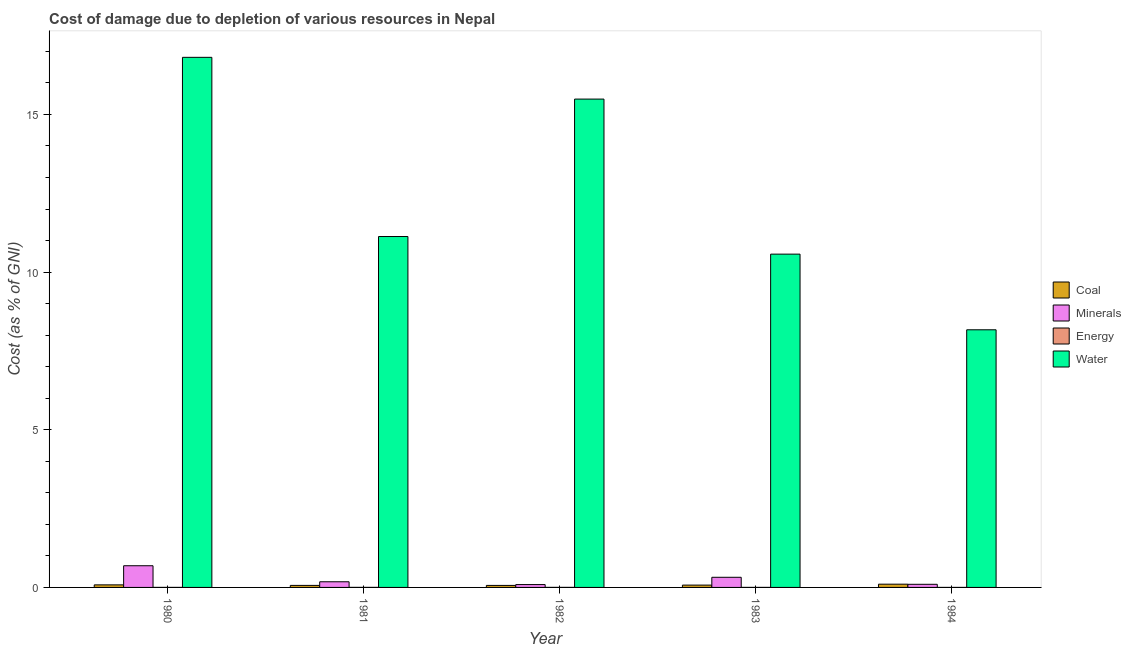How many different coloured bars are there?
Provide a short and direct response. 4. How many bars are there on the 1st tick from the left?
Provide a succinct answer. 4. What is the label of the 4th group of bars from the left?
Keep it short and to the point. 1983. What is the cost of damage due to depletion of coal in 1980?
Offer a terse response. 0.08. Across all years, what is the maximum cost of damage due to depletion of energy?
Your response must be concise. 0. Across all years, what is the minimum cost of damage due to depletion of energy?
Your response must be concise. 0. In which year was the cost of damage due to depletion of minerals maximum?
Make the answer very short. 1980. What is the total cost of damage due to depletion of coal in the graph?
Keep it short and to the point. 0.39. What is the difference between the cost of damage due to depletion of minerals in 1980 and that in 1984?
Your response must be concise. 0.59. What is the difference between the cost of damage due to depletion of coal in 1981 and the cost of damage due to depletion of water in 1983?
Your answer should be compact. -0.01. What is the average cost of damage due to depletion of energy per year?
Offer a very short reply. 0. In the year 1982, what is the difference between the cost of damage due to depletion of energy and cost of damage due to depletion of minerals?
Your answer should be very brief. 0. In how many years, is the cost of damage due to depletion of energy greater than 15 %?
Provide a short and direct response. 0. What is the ratio of the cost of damage due to depletion of coal in 1980 to that in 1981?
Your answer should be very brief. 1.26. What is the difference between the highest and the second highest cost of damage due to depletion of water?
Offer a very short reply. 1.32. What is the difference between the highest and the lowest cost of damage due to depletion of energy?
Make the answer very short. 0. Is the sum of the cost of damage due to depletion of coal in 1980 and 1982 greater than the maximum cost of damage due to depletion of water across all years?
Ensure brevity in your answer.  Yes. What does the 4th bar from the left in 1982 represents?
Your answer should be very brief. Water. What does the 1st bar from the right in 1980 represents?
Ensure brevity in your answer.  Water. Are all the bars in the graph horizontal?
Your answer should be very brief. No. How many years are there in the graph?
Your response must be concise. 5. Are the values on the major ticks of Y-axis written in scientific E-notation?
Your answer should be very brief. No. How many legend labels are there?
Keep it short and to the point. 4. What is the title of the graph?
Ensure brevity in your answer.  Cost of damage due to depletion of various resources in Nepal . Does "Agricultural land" appear as one of the legend labels in the graph?
Your response must be concise. No. What is the label or title of the Y-axis?
Ensure brevity in your answer.  Cost (as % of GNI). What is the Cost (as % of GNI) of Coal in 1980?
Offer a very short reply. 0.08. What is the Cost (as % of GNI) of Minerals in 1980?
Provide a succinct answer. 0.69. What is the Cost (as % of GNI) of Energy in 1980?
Provide a succinct answer. 0. What is the Cost (as % of GNI) in Water in 1980?
Make the answer very short. 16.81. What is the Cost (as % of GNI) in Coal in 1981?
Keep it short and to the point. 0.06. What is the Cost (as % of GNI) in Minerals in 1981?
Give a very brief answer. 0.18. What is the Cost (as % of GNI) in Energy in 1981?
Offer a very short reply. 0. What is the Cost (as % of GNI) of Water in 1981?
Provide a succinct answer. 11.13. What is the Cost (as % of GNI) in Coal in 1982?
Provide a succinct answer. 0.06. What is the Cost (as % of GNI) of Minerals in 1982?
Offer a very short reply. 0.09. What is the Cost (as % of GNI) of Energy in 1982?
Keep it short and to the point. 0. What is the Cost (as % of GNI) in Water in 1982?
Give a very brief answer. 15.49. What is the Cost (as % of GNI) of Coal in 1983?
Your answer should be compact. 0.07. What is the Cost (as % of GNI) of Minerals in 1983?
Keep it short and to the point. 0.32. What is the Cost (as % of GNI) in Energy in 1983?
Your response must be concise. 0. What is the Cost (as % of GNI) in Water in 1983?
Ensure brevity in your answer.  10.57. What is the Cost (as % of GNI) of Coal in 1984?
Your answer should be very brief. 0.1. What is the Cost (as % of GNI) of Minerals in 1984?
Give a very brief answer. 0.1. What is the Cost (as % of GNI) of Energy in 1984?
Ensure brevity in your answer.  0. What is the Cost (as % of GNI) in Water in 1984?
Provide a short and direct response. 8.17. Across all years, what is the maximum Cost (as % of GNI) of Coal?
Keep it short and to the point. 0.1. Across all years, what is the maximum Cost (as % of GNI) of Minerals?
Your response must be concise. 0.69. Across all years, what is the maximum Cost (as % of GNI) in Energy?
Ensure brevity in your answer.  0. Across all years, what is the maximum Cost (as % of GNI) in Water?
Your response must be concise. 16.81. Across all years, what is the minimum Cost (as % of GNI) in Coal?
Give a very brief answer. 0.06. Across all years, what is the minimum Cost (as % of GNI) of Minerals?
Your answer should be very brief. 0.09. Across all years, what is the minimum Cost (as % of GNI) of Energy?
Give a very brief answer. 0. Across all years, what is the minimum Cost (as % of GNI) in Water?
Provide a succinct answer. 8.17. What is the total Cost (as % of GNI) in Coal in the graph?
Your response must be concise. 0.39. What is the total Cost (as % of GNI) of Minerals in the graph?
Provide a short and direct response. 1.38. What is the total Cost (as % of GNI) of Energy in the graph?
Give a very brief answer. 0. What is the total Cost (as % of GNI) of Water in the graph?
Make the answer very short. 62.17. What is the difference between the Cost (as % of GNI) of Coal in 1980 and that in 1981?
Ensure brevity in your answer.  0.02. What is the difference between the Cost (as % of GNI) in Minerals in 1980 and that in 1981?
Ensure brevity in your answer.  0.51. What is the difference between the Cost (as % of GNI) in Energy in 1980 and that in 1981?
Offer a very short reply. -0. What is the difference between the Cost (as % of GNI) of Water in 1980 and that in 1981?
Your answer should be very brief. 5.68. What is the difference between the Cost (as % of GNI) of Coal in 1980 and that in 1982?
Give a very brief answer. 0.02. What is the difference between the Cost (as % of GNI) in Minerals in 1980 and that in 1982?
Make the answer very short. 0.6. What is the difference between the Cost (as % of GNI) of Energy in 1980 and that in 1982?
Offer a very short reply. -0. What is the difference between the Cost (as % of GNI) in Water in 1980 and that in 1982?
Provide a short and direct response. 1.32. What is the difference between the Cost (as % of GNI) in Coal in 1980 and that in 1983?
Ensure brevity in your answer.  0.01. What is the difference between the Cost (as % of GNI) in Minerals in 1980 and that in 1983?
Make the answer very short. 0.37. What is the difference between the Cost (as % of GNI) in Energy in 1980 and that in 1983?
Your answer should be very brief. -0. What is the difference between the Cost (as % of GNI) of Water in 1980 and that in 1983?
Ensure brevity in your answer.  6.24. What is the difference between the Cost (as % of GNI) in Coal in 1980 and that in 1984?
Provide a short and direct response. -0.02. What is the difference between the Cost (as % of GNI) of Minerals in 1980 and that in 1984?
Ensure brevity in your answer.  0.59. What is the difference between the Cost (as % of GNI) of Water in 1980 and that in 1984?
Make the answer very short. 8.64. What is the difference between the Cost (as % of GNI) of Coal in 1981 and that in 1982?
Make the answer very short. 0. What is the difference between the Cost (as % of GNI) of Minerals in 1981 and that in 1982?
Offer a terse response. 0.09. What is the difference between the Cost (as % of GNI) of Energy in 1981 and that in 1982?
Your answer should be compact. -0. What is the difference between the Cost (as % of GNI) of Water in 1981 and that in 1982?
Offer a terse response. -4.36. What is the difference between the Cost (as % of GNI) of Coal in 1981 and that in 1983?
Offer a very short reply. -0.01. What is the difference between the Cost (as % of GNI) of Minerals in 1981 and that in 1983?
Keep it short and to the point. -0.14. What is the difference between the Cost (as % of GNI) of Water in 1981 and that in 1983?
Ensure brevity in your answer.  0.56. What is the difference between the Cost (as % of GNI) in Coal in 1981 and that in 1984?
Provide a succinct answer. -0.04. What is the difference between the Cost (as % of GNI) of Minerals in 1981 and that in 1984?
Your response must be concise. 0.08. What is the difference between the Cost (as % of GNI) of Energy in 1981 and that in 1984?
Your answer should be compact. 0. What is the difference between the Cost (as % of GNI) in Water in 1981 and that in 1984?
Provide a short and direct response. 2.96. What is the difference between the Cost (as % of GNI) in Coal in 1982 and that in 1983?
Offer a very short reply. -0.01. What is the difference between the Cost (as % of GNI) in Minerals in 1982 and that in 1983?
Offer a terse response. -0.23. What is the difference between the Cost (as % of GNI) in Energy in 1982 and that in 1983?
Offer a very short reply. 0. What is the difference between the Cost (as % of GNI) in Water in 1982 and that in 1983?
Provide a short and direct response. 4.92. What is the difference between the Cost (as % of GNI) in Coal in 1982 and that in 1984?
Provide a succinct answer. -0.04. What is the difference between the Cost (as % of GNI) of Minerals in 1982 and that in 1984?
Make the answer very short. -0.01. What is the difference between the Cost (as % of GNI) in Water in 1982 and that in 1984?
Provide a succinct answer. 7.32. What is the difference between the Cost (as % of GNI) in Coal in 1983 and that in 1984?
Offer a terse response. -0.03. What is the difference between the Cost (as % of GNI) in Minerals in 1983 and that in 1984?
Offer a very short reply. 0.22. What is the difference between the Cost (as % of GNI) of Water in 1983 and that in 1984?
Ensure brevity in your answer.  2.4. What is the difference between the Cost (as % of GNI) of Coal in 1980 and the Cost (as % of GNI) of Minerals in 1981?
Your answer should be very brief. -0.1. What is the difference between the Cost (as % of GNI) in Coal in 1980 and the Cost (as % of GNI) in Energy in 1981?
Offer a very short reply. 0.08. What is the difference between the Cost (as % of GNI) of Coal in 1980 and the Cost (as % of GNI) of Water in 1981?
Make the answer very short. -11.05. What is the difference between the Cost (as % of GNI) in Minerals in 1980 and the Cost (as % of GNI) in Energy in 1981?
Ensure brevity in your answer.  0.69. What is the difference between the Cost (as % of GNI) in Minerals in 1980 and the Cost (as % of GNI) in Water in 1981?
Keep it short and to the point. -10.44. What is the difference between the Cost (as % of GNI) in Energy in 1980 and the Cost (as % of GNI) in Water in 1981?
Your response must be concise. -11.13. What is the difference between the Cost (as % of GNI) of Coal in 1980 and the Cost (as % of GNI) of Minerals in 1982?
Provide a short and direct response. -0.01. What is the difference between the Cost (as % of GNI) in Coal in 1980 and the Cost (as % of GNI) in Energy in 1982?
Make the answer very short. 0.08. What is the difference between the Cost (as % of GNI) in Coal in 1980 and the Cost (as % of GNI) in Water in 1982?
Ensure brevity in your answer.  -15.41. What is the difference between the Cost (as % of GNI) of Minerals in 1980 and the Cost (as % of GNI) of Energy in 1982?
Offer a terse response. 0.69. What is the difference between the Cost (as % of GNI) in Minerals in 1980 and the Cost (as % of GNI) in Water in 1982?
Keep it short and to the point. -14.8. What is the difference between the Cost (as % of GNI) of Energy in 1980 and the Cost (as % of GNI) of Water in 1982?
Your response must be concise. -15.49. What is the difference between the Cost (as % of GNI) in Coal in 1980 and the Cost (as % of GNI) in Minerals in 1983?
Provide a succinct answer. -0.24. What is the difference between the Cost (as % of GNI) in Coal in 1980 and the Cost (as % of GNI) in Energy in 1983?
Ensure brevity in your answer.  0.08. What is the difference between the Cost (as % of GNI) of Coal in 1980 and the Cost (as % of GNI) of Water in 1983?
Your answer should be compact. -10.49. What is the difference between the Cost (as % of GNI) in Minerals in 1980 and the Cost (as % of GNI) in Energy in 1983?
Provide a short and direct response. 0.69. What is the difference between the Cost (as % of GNI) in Minerals in 1980 and the Cost (as % of GNI) in Water in 1983?
Your answer should be compact. -9.88. What is the difference between the Cost (as % of GNI) in Energy in 1980 and the Cost (as % of GNI) in Water in 1983?
Ensure brevity in your answer.  -10.57. What is the difference between the Cost (as % of GNI) in Coal in 1980 and the Cost (as % of GNI) in Minerals in 1984?
Your response must be concise. -0.02. What is the difference between the Cost (as % of GNI) in Coal in 1980 and the Cost (as % of GNI) in Energy in 1984?
Ensure brevity in your answer.  0.08. What is the difference between the Cost (as % of GNI) in Coal in 1980 and the Cost (as % of GNI) in Water in 1984?
Ensure brevity in your answer.  -8.09. What is the difference between the Cost (as % of GNI) of Minerals in 1980 and the Cost (as % of GNI) of Energy in 1984?
Your answer should be very brief. 0.69. What is the difference between the Cost (as % of GNI) in Minerals in 1980 and the Cost (as % of GNI) in Water in 1984?
Provide a succinct answer. -7.48. What is the difference between the Cost (as % of GNI) in Energy in 1980 and the Cost (as % of GNI) in Water in 1984?
Offer a very short reply. -8.17. What is the difference between the Cost (as % of GNI) of Coal in 1981 and the Cost (as % of GNI) of Minerals in 1982?
Your answer should be very brief. -0.03. What is the difference between the Cost (as % of GNI) of Coal in 1981 and the Cost (as % of GNI) of Energy in 1982?
Keep it short and to the point. 0.06. What is the difference between the Cost (as % of GNI) of Coal in 1981 and the Cost (as % of GNI) of Water in 1982?
Make the answer very short. -15.42. What is the difference between the Cost (as % of GNI) in Minerals in 1981 and the Cost (as % of GNI) in Energy in 1982?
Provide a succinct answer. 0.18. What is the difference between the Cost (as % of GNI) of Minerals in 1981 and the Cost (as % of GNI) of Water in 1982?
Offer a very short reply. -15.31. What is the difference between the Cost (as % of GNI) in Energy in 1981 and the Cost (as % of GNI) in Water in 1982?
Keep it short and to the point. -15.49. What is the difference between the Cost (as % of GNI) in Coal in 1981 and the Cost (as % of GNI) in Minerals in 1983?
Your answer should be compact. -0.26. What is the difference between the Cost (as % of GNI) in Coal in 1981 and the Cost (as % of GNI) in Energy in 1983?
Your answer should be compact. 0.06. What is the difference between the Cost (as % of GNI) of Coal in 1981 and the Cost (as % of GNI) of Water in 1983?
Offer a very short reply. -10.51. What is the difference between the Cost (as % of GNI) in Minerals in 1981 and the Cost (as % of GNI) in Energy in 1983?
Your response must be concise. 0.18. What is the difference between the Cost (as % of GNI) of Minerals in 1981 and the Cost (as % of GNI) of Water in 1983?
Offer a very short reply. -10.39. What is the difference between the Cost (as % of GNI) in Energy in 1981 and the Cost (as % of GNI) in Water in 1983?
Your response must be concise. -10.57. What is the difference between the Cost (as % of GNI) in Coal in 1981 and the Cost (as % of GNI) in Minerals in 1984?
Make the answer very short. -0.03. What is the difference between the Cost (as % of GNI) in Coal in 1981 and the Cost (as % of GNI) in Energy in 1984?
Make the answer very short. 0.06. What is the difference between the Cost (as % of GNI) in Coal in 1981 and the Cost (as % of GNI) in Water in 1984?
Keep it short and to the point. -8.11. What is the difference between the Cost (as % of GNI) of Minerals in 1981 and the Cost (as % of GNI) of Energy in 1984?
Ensure brevity in your answer.  0.18. What is the difference between the Cost (as % of GNI) of Minerals in 1981 and the Cost (as % of GNI) of Water in 1984?
Give a very brief answer. -7.99. What is the difference between the Cost (as % of GNI) of Energy in 1981 and the Cost (as % of GNI) of Water in 1984?
Give a very brief answer. -8.17. What is the difference between the Cost (as % of GNI) in Coal in 1982 and the Cost (as % of GNI) in Minerals in 1983?
Keep it short and to the point. -0.26. What is the difference between the Cost (as % of GNI) in Coal in 1982 and the Cost (as % of GNI) in Energy in 1983?
Offer a very short reply. 0.06. What is the difference between the Cost (as % of GNI) in Coal in 1982 and the Cost (as % of GNI) in Water in 1983?
Offer a very short reply. -10.51. What is the difference between the Cost (as % of GNI) of Minerals in 1982 and the Cost (as % of GNI) of Energy in 1983?
Keep it short and to the point. 0.09. What is the difference between the Cost (as % of GNI) in Minerals in 1982 and the Cost (as % of GNI) in Water in 1983?
Your response must be concise. -10.48. What is the difference between the Cost (as % of GNI) in Energy in 1982 and the Cost (as % of GNI) in Water in 1983?
Offer a terse response. -10.57. What is the difference between the Cost (as % of GNI) of Coal in 1982 and the Cost (as % of GNI) of Minerals in 1984?
Your response must be concise. -0.04. What is the difference between the Cost (as % of GNI) in Coal in 1982 and the Cost (as % of GNI) in Energy in 1984?
Provide a short and direct response. 0.06. What is the difference between the Cost (as % of GNI) in Coal in 1982 and the Cost (as % of GNI) in Water in 1984?
Offer a very short reply. -8.11. What is the difference between the Cost (as % of GNI) in Minerals in 1982 and the Cost (as % of GNI) in Energy in 1984?
Make the answer very short. 0.09. What is the difference between the Cost (as % of GNI) of Minerals in 1982 and the Cost (as % of GNI) of Water in 1984?
Make the answer very short. -8.08. What is the difference between the Cost (as % of GNI) in Energy in 1982 and the Cost (as % of GNI) in Water in 1984?
Give a very brief answer. -8.17. What is the difference between the Cost (as % of GNI) of Coal in 1983 and the Cost (as % of GNI) of Minerals in 1984?
Your answer should be very brief. -0.03. What is the difference between the Cost (as % of GNI) of Coal in 1983 and the Cost (as % of GNI) of Energy in 1984?
Ensure brevity in your answer.  0.07. What is the difference between the Cost (as % of GNI) in Coal in 1983 and the Cost (as % of GNI) in Water in 1984?
Offer a terse response. -8.1. What is the difference between the Cost (as % of GNI) of Minerals in 1983 and the Cost (as % of GNI) of Energy in 1984?
Make the answer very short. 0.32. What is the difference between the Cost (as % of GNI) of Minerals in 1983 and the Cost (as % of GNI) of Water in 1984?
Your answer should be very brief. -7.85. What is the difference between the Cost (as % of GNI) in Energy in 1983 and the Cost (as % of GNI) in Water in 1984?
Ensure brevity in your answer.  -8.17. What is the average Cost (as % of GNI) of Coal per year?
Make the answer very short. 0.08. What is the average Cost (as % of GNI) in Minerals per year?
Your response must be concise. 0.28. What is the average Cost (as % of GNI) of Energy per year?
Keep it short and to the point. 0. What is the average Cost (as % of GNI) of Water per year?
Offer a very short reply. 12.43. In the year 1980, what is the difference between the Cost (as % of GNI) of Coal and Cost (as % of GNI) of Minerals?
Offer a terse response. -0.61. In the year 1980, what is the difference between the Cost (as % of GNI) in Coal and Cost (as % of GNI) in Energy?
Keep it short and to the point. 0.08. In the year 1980, what is the difference between the Cost (as % of GNI) of Coal and Cost (as % of GNI) of Water?
Give a very brief answer. -16.73. In the year 1980, what is the difference between the Cost (as % of GNI) of Minerals and Cost (as % of GNI) of Energy?
Give a very brief answer. 0.69. In the year 1980, what is the difference between the Cost (as % of GNI) of Minerals and Cost (as % of GNI) of Water?
Provide a succinct answer. -16.12. In the year 1980, what is the difference between the Cost (as % of GNI) in Energy and Cost (as % of GNI) in Water?
Your response must be concise. -16.81. In the year 1981, what is the difference between the Cost (as % of GNI) in Coal and Cost (as % of GNI) in Minerals?
Keep it short and to the point. -0.12. In the year 1981, what is the difference between the Cost (as % of GNI) in Coal and Cost (as % of GNI) in Energy?
Give a very brief answer. 0.06. In the year 1981, what is the difference between the Cost (as % of GNI) in Coal and Cost (as % of GNI) in Water?
Ensure brevity in your answer.  -11.06. In the year 1981, what is the difference between the Cost (as % of GNI) in Minerals and Cost (as % of GNI) in Energy?
Make the answer very short. 0.18. In the year 1981, what is the difference between the Cost (as % of GNI) in Minerals and Cost (as % of GNI) in Water?
Ensure brevity in your answer.  -10.95. In the year 1981, what is the difference between the Cost (as % of GNI) in Energy and Cost (as % of GNI) in Water?
Provide a short and direct response. -11.13. In the year 1982, what is the difference between the Cost (as % of GNI) of Coal and Cost (as % of GNI) of Minerals?
Your response must be concise. -0.03. In the year 1982, what is the difference between the Cost (as % of GNI) in Coal and Cost (as % of GNI) in Energy?
Offer a very short reply. 0.06. In the year 1982, what is the difference between the Cost (as % of GNI) in Coal and Cost (as % of GNI) in Water?
Ensure brevity in your answer.  -15.42. In the year 1982, what is the difference between the Cost (as % of GNI) of Minerals and Cost (as % of GNI) of Energy?
Offer a terse response. 0.09. In the year 1982, what is the difference between the Cost (as % of GNI) of Minerals and Cost (as % of GNI) of Water?
Your response must be concise. -15.4. In the year 1982, what is the difference between the Cost (as % of GNI) in Energy and Cost (as % of GNI) in Water?
Provide a succinct answer. -15.49. In the year 1983, what is the difference between the Cost (as % of GNI) of Coal and Cost (as % of GNI) of Minerals?
Provide a short and direct response. -0.25. In the year 1983, what is the difference between the Cost (as % of GNI) of Coal and Cost (as % of GNI) of Energy?
Offer a terse response. 0.07. In the year 1983, what is the difference between the Cost (as % of GNI) in Coal and Cost (as % of GNI) in Water?
Keep it short and to the point. -10.5. In the year 1983, what is the difference between the Cost (as % of GNI) in Minerals and Cost (as % of GNI) in Energy?
Your answer should be compact. 0.32. In the year 1983, what is the difference between the Cost (as % of GNI) of Minerals and Cost (as % of GNI) of Water?
Your response must be concise. -10.25. In the year 1983, what is the difference between the Cost (as % of GNI) of Energy and Cost (as % of GNI) of Water?
Provide a short and direct response. -10.57. In the year 1984, what is the difference between the Cost (as % of GNI) of Coal and Cost (as % of GNI) of Minerals?
Offer a terse response. 0. In the year 1984, what is the difference between the Cost (as % of GNI) of Coal and Cost (as % of GNI) of Energy?
Provide a succinct answer. 0.1. In the year 1984, what is the difference between the Cost (as % of GNI) in Coal and Cost (as % of GNI) in Water?
Offer a terse response. -8.07. In the year 1984, what is the difference between the Cost (as % of GNI) of Minerals and Cost (as % of GNI) of Energy?
Offer a very short reply. 0.1. In the year 1984, what is the difference between the Cost (as % of GNI) in Minerals and Cost (as % of GNI) in Water?
Keep it short and to the point. -8.07. In the year 1984, what is the difference between the Cost (as % of GNI) in Energy and Cost (as % of GNI) in Water?
Give a very brief answer. -8.17. What is the ratio of the Cost (as % of GNI) of Coal in 1980 to that in 1981?
Your response must be concise. 1.26. What is the ratio of the Cost (as % of GNI) in Minerals in 1980 to that in 1981?
Your response must be concise. 3.83. What is the ratio of the Cost (as % of GNI) of Energy in 1980 to that in 1981?
Keep it short and to the point. 0.51. What is the ratio of the Cost (as % of GNI) in Water in 1980 to that in 1981?
Your answer should be very brief. 1.51. What is the ratio of the Cost (as % of GNI) in Coal in 1980 to that in 1982?
Provide a short and direct response. 1.27. What is the ratio of the Cost (as % of GNI) in Minerals in 1980 to that in 1982?
Your answer should be compact. 7.59. What is the ratio of the Cost (as % of GNI) of Energy in 1980 to that in 1982?
Your response must be concise. 0.46. What is the ratio of the Cost (as % of GNI) in Water in 1980 to that in 1982?
Keep it short and to the point. 1.09. What is the ratio of the Cost (as % of GNI) in Coal in 1980 to that in 1983?
Your answer should be compact. 1.1. What is the ratio of the Cost (as % of GNI) of Minerals in 1980 to that in 1983?
Ensure brevity in your answer.  2.14. What is the ratio of the Cost (as % of GNI) in Energy in 1980 to that in 1983?
Keep it short and to the point. 0.85. What is the ratio of the Cost (as % of GNI) of Water in 1980 to that in 1983?
Provide a succinct answer. 1.59. What is the ratio of the Cost (as % of GNI) of Coal in 1980 to that in 1984?
Your answer should be compact. 0.79. What is the ratio of the Cost (as % of GNI) in Minerals in 1980 to that in 1984?
Make the answer very short. 6.94. What is the ratio of the Cost (as % of GNI) of Energy in 1980 to that in 1984?
Your response must be concise. 1.4. What is the ratio of the Cost (as % of GNI) of Water in 1980 to that in 1984?
Your answer should be compact. 2.06. What is the ratio of the Cost (as % of GNI) of Minerals in 1981 to that in 1982?
Ensure brevity in your answer.  1.98. What is the ratio of the Cost (as % of GNI) in Energy in 1981 to that in 1982?
Your answer should be compact. 0.89. What is the ratio of the Cost (as % of GNI) in Water in 1981 to that in 1982?
Make the answer very short. 0.72. What is the ratio of the Cost (as % of GNI) of Coal in 1981 to that in 1983?
Ensure brevity in your answer.  0.87. What is the ratio of the Cost (as % of GNI) in Minerals in 1981 to that in 1983?
Your response must be concise. 0.56. What is the ratio of the Cost (as % of GNI) in Energy in 1981 to that in 1983?
Your response must be concise. 1.66. What is the ratio of the Cost (as % of GNI) of Water in 1981 to that in 1983?
Make the answer very short. 1.05. What is the ratio of the Cost (as % of GNI) in Coal in 1981 to that in 1984?
Your answer should be compact. 0.63. What is the ratio of the Cost (as % of GNI) in Minerals in 1981 to that in 1984?
Your answer should be very brief. 1.81. What is the ratio of the Cost (as % of GNI) of Energy in 1981 to that in 1984?
Give a very brief answer. 2.73. What is the ratio of the Cost (as % of GNI) of Water in 1981 to that in 1984?
Keep it short and to the point. 1.36. What is the ratio of the Cost (as % of GNI) in Coal in 1982 to that in 1983?
Provide a succinct answer. 0.87. What is the ratio of the Cost (as % of GNI) in Minerals in 1982 to that in 1983?
Give a very brief answer. 0.28. What is the ratio of the Cost (as % of GNI) of Energy in 1982 to that in 1983?
Provide a succinct answer. 1.86. What is the ratio of the Cost (as % of GNI) in Water in 1982 to that in 1983?
Your response must be concise. 1.47. What is the ratio of the Cost (as % of GNI) of Coal in 1982 to that in 1984?
Offer a terse response. 0.62. What is the ratio of the Cost (as % of GNI) of Minerals in 1982 to that in 1984?
Ensure brevity in your answer.  0.91. What is the ratio of the Cost (as % of GNI) of Energy in 1982 to that in 1984?
Provide a succinct answer. 3.08. What is the ratio of the Cost (as % of GNI) in Water in 1982 to that in 1984?
Your answer should be compact. 1.9. What is the ratio of the Cost (as % of GNI) in Coal in 1983 to that in 1984?
Offer a very short reply. 0.72. What is the ratio of the Cost (as % of GNI) of Minerals in 1983 to that in 1984?
Ensure brevity in your answer.  3.24. What is the ratio of the Cost (as % of GNI) in Energy in 1983 to that in 1984?
Offer a very short reply. 1.65. What is the ratio of the Cost (as % of GNI) of Water in 1983 to that in 1984?
Make the answer very short. 1.29. What is the difference between the highest and the second highest Cost (as % of GNI) of Coal?
Your answer should be very brief. 0.02. What is the difference between the highest and the second highest Cost (as % of GNI) of Minerals?
Your answer should be compact. 0.37. What is the difference between the highest and the second highest Cost (as % of GNI) of Water?
Provide a short and direct response. 1.32. What is the difference between the highest and the lowest Cost (as % of GNI) of Coal?
Provide a short and direct response. 0.04. What is the difference between the highest and the lowest Cost (as % of GNI) of Minerals?
Your answer should be compact. 0.6. What is the difference between the highest and the lowest Cost (as % of GNI) of Energy?
Provide a short and direct response. 0. What is the difference between the highest and the lowest Cost (as % of GNI) in Water?
Offer a very short reply. 8.64. 